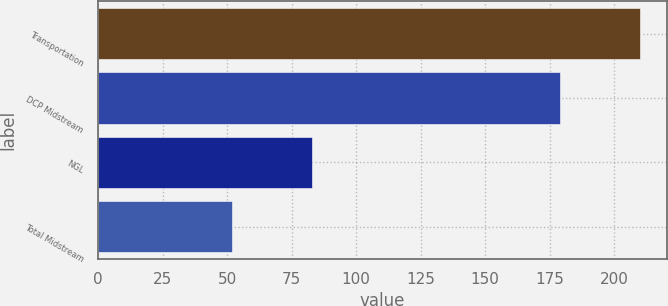Convert chart to OTSL. <chart><loc_0><loc_0><loc_500><loc_500><bar_chart><fcel>Transportation<fcel>DCP Midstream<fcel>NGL<fcel>Total Midstream<nl><fcel>210<fcel>179<fcel>83<fcel>52<nl></chart> 